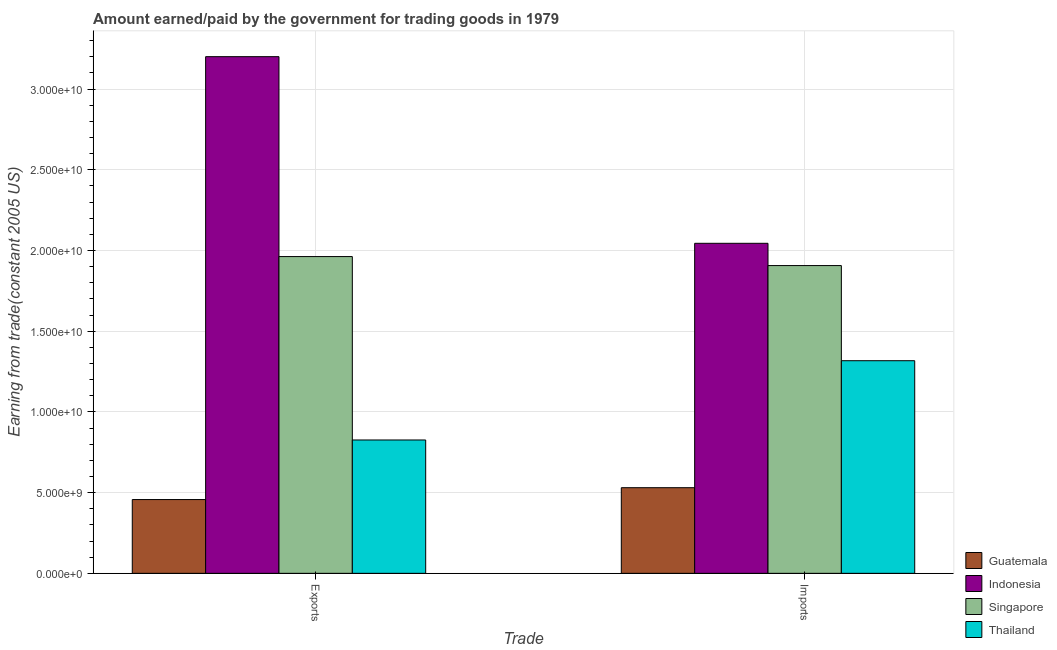How many different coloured bars are there?
Provide a succinct answer. 4. Are the number of bars on each tick of the X-axis equal?
Ensure brevity in your answer.  Yes. How many bars are there on the 2nd tick from the left?
Keep it short and to the point. 4. How many bars are there on the 2nd tick from the right?
Provide a succinct answer. 4. What is the label of the 1st group of bars from the left?
Your answer should be compact. Exports. What is the amount earned from exports in Guatemala?
Make the answer very short. 4.57e+09. Across all countries, what is the maximum amount earned from exports?
Provide a short and direct response. 3.20e+1. Across all countries, what is the minimum amount earned from exports?
Keep it short and to the point. 4.57e+09. In which country was the amount earned from exports minimum?
Your response must be concise. Guatemala. What is the total amount earned from exports in the graph?
Provide a succinct answer. 6.45e+1. What is the difference between the amount earned from exports in Singapore and that in Indonesia?
Keep it short and to the point. -1.24e+1. What is the difference between the amount paid for imports in Thailand and the amount earned from exports in Guatemala?
Provide a succinct answer. 8.60e+09. What is the average amount earned from exports per country?
Keep it short and to the point. 1.61e+1. What is the difference between the amount earned from exports and amount paid for imports in Guatemala?
Your response must be concise. -7.34e+08. What is the ratio of the amount earned from exports in Thailand to that in Guatemala?
Your response must be concise. 1.81. In how many countries, is the amount paid for imports greater than the average amount paid for imports taken over all countries?
Offer a terse response. 2. What does the 4th bar from the left in Imports represents?
Keep it short and to the point. Thailand. What does the 2nd bar from the right in Exports represents?
Offer a terse response. Singapore. Are all the bars in the graph horizontal?
Keep it short and to the point. No. Are the values on the major ticks of Y-axis written in scientific E-notation?
Ensure brevity in your answer.  Yes. Does the graph contain any zero values?
Make the answer very short. No. Does the graph contain grids?
Your answer should be very brief. Yes. Where does the legend appear in the graph?
Your answer should be compact. Bottom right. How many legend labels are there?
Your answer should be very brief. 4. What is the title of the graph?
Your response must be concise. Amount earned/paid by the government for trading goods in 1979. Does "Equatorial Guinea" appear as one of the legend labels in the graph?
Offer a very short reply. No. What is the label or title of the X-axis?
Your response must be concise. Trade. What is the label or title of the Y-axis?
Your response must be concise. Earning from trade(constant 2005 US). What is the Earning from trade(constant 2005 US) in Guatemala in Exports?
Give a very brief answer. 4.57e+09. What is the Earning from trade(constant 2005 US) of Indonesia in Exports?
Ensure brevity in your answer.  3.20e+1. What is the Earning from trade(constant 2005 US) in Singapore in Exports?
Offer a terse response. 1.96e+1. What is the Earning from trade(constant 2005 US) in Thailand in Exports?
Ensure brevity in your answer.  8.26e+09. What is the Earning from trade(constant 2005 US) in Guatemala in Imports?
Provide a short and direct response. 5.31e+09. What is the Earning from trade(constant 2005 US) in Indonesia in Imports?
Keep it short and to the point. 2.04e+1. What is the Earning from trade(constant 2005 US) of Singapore in Imports?
Your answer should be very brief. 1.91e+1. What is the Earning from trade(constant 2005 US) in Thailand in Imports?
Offer a terse response. 1.32e+1. Across all Trade, what is the maximum Earning from trade(constant 2005 US) in Guatemala?
Ensure brevity in your answer.  5.31e+09. Across all Trade, what is the maximum Earning from trade(constant 2005 US) of Indonesia?
Offer a very short reply. 3.20e+1. Across all Trade, what is the maximum Earning from trade(constant 2005 US) of Singapore?
Your answer should be compact. 1.96e+1. Across all Trade, what is the maximum Earning from trade(constant 2005 US) in Thailand?
Your answer should be compact. 1.32e+1. Across all Trade, what is the minimum Earning from trade(constant 2005 US) of Guatemala?
Offer a very short reply. 4.57e+09. Across all Trade, what is the minimum Earning from trade(constant 2005 US) in Indonesia?
Offer a very short reply. 2.04e+1. Across all Trade, what is the minimum Earning from trade(constant 2005 US) of Singapore?
Offer a very short reply. 1.91e+1. Across all Trade, what is the minimum Earning from trade(constant 2005 US) of Thailand?
Offer a very short reply. 8.26e+09. What is the total Earning from trade(constant 2005 US) in Guatemala in the graph?
Offer a terse response. 9.88e+09. What is the total Earning from trade(constant 2005 US) in Indonesia in the graph?
Your answer should be very brief. 5.25e+1. What is the total Earning from trade(constant 2005 US) in Singapore in the graph?
Make the answer very short. 3.87e+1. What is the total Earning from trade(constant 2005 US) of Thailand in the graph?
Ensure brevity in your answer.  2.14e+1. What is the difference between the Earning from trade(constant 2005 US) in Guatemala in Exports and that in Imports?
Keep it short and to the point. -7.34e+08. What is the difference between the Earning from trade(constant 2005 US) in Indonesia in Exports and that in Imports?
Keep it short and to the point. 1.16e+1. What is the difference between the Earning from trade(constant 2005 US) of Singapore in Exports and that in Imports?
Ensure brevity in your answer.  5.58e+08. What is the difference between the Earning from trade(constant 2005 US) of Thailand in Exports and that in Imports?
Provide a succinct answer. -4.91e+09. What is the difference between the Earning from trade(constant 2005 US) in Guatemala in Exports and the Earning from trade(constant 2005 US) in Indonesia in Imports?
Make the answer very short. -1.59e+1. What is the difference between the Earning from trade(constant 2005 US) in Guatemala in Exports and the Earning from trade(constant 2005 US) in Singapore in Imports?
Offer a terse response. -1.45e+1. What is the difference between the Earning from trade(constant 2005 US) in Guatemala in Exports and the Earning from trade(constant 2005 US) in Thailand in Imports?
Offer a very short reply. -8.60e+09. What is the difference between the Earning from trade(constant 2005 US) in Indonesia in Exports and the Earning from trade(constant 2005 US) in Singapore in Imports?
Give a very brief answer. 1.29e+1. What is the difference between the Earning from trade(constant 2005 US) of Indonesia in Exports and the Earning from trade(constant 2005 US) of Thailand in Imports?
Make the answer very short. 1.88e+1. What is the difference between the Earning from trade(constant 2005 US) in Singapore in Exports and the Earning from trade(constant 2005 US) in Thailand in Imports?
Keep it short and to the point. 6.45e+09. What is the average Earning from trade(constant 2005 US) of Guatemala per Trade?
Make the answer very short. 4.94e+09. What is the average Earning from trade(constant 2005 US) of Indonesia per Trade?
Your answer should be compact. 2.62e+1. What is the average Earning from trade(constant 2005 US) in Singapore per Trade?
Your answer should be compact. 1.93e+1. What is the average Earning from trade(constant 2005 US) of Thailand per Trade?
Your response must be concise. 1.07e+1. What is the difference between the Earning from trade(constant 2005 US) of Guatemala and Earning from trade(constant 2005 US) of Indonesia in Exports?
Your answer should be very brief. -2.74e+1. What is the difference between the Earning from trade(constant 2005 US) in Guatemala and Earning from trade(constant 2005 US) in Singapore in Exports?
Provide a short and direct response. -1.51e+1. What is the difference between the Earning from trade(constant 2005 US) of Guatemala and Earning from trade(constant 2005 US) of Thailand in Exports?
Provide a short and direct response. -3.69e+09. What is the difference between the Earning from trade(constant 2005 US) of Indonesia and Earning from trade(constant 2005 US) of Singapore in Exports?
Offer a very short reply. 1.24e+1. What is the difference between the Earning from trade(constant 2005 US) of Indonesia and Earning from trade(constant 2005 US) of Thailand in Exports?
Provide a short and direct response. 2.37e+1. What is the difference between the Earning from trade(constant 2005 US) of Singapore and Earning from trade(constant 2005 US) of Thailand in Exports?
Keep it short and to the point. 1.14e+1. What is the difference between the Earning from trade(constant 2005 US) in Guatemala and Earning from trade(constant 2005 US) in Indonesia in Imports?
Your answer should be very brief. -1.51e+1. What is the difference between the Earning from trade(constant 2005 US) in Guatemala and Earning from trade(constant 2005 US) in Singapore in Imports?
Give a very brief answer. -1.38e+1. What is the difference between the Earning from trade(constant 2005 US) of Guatemala and Earning from trade(constant 2005 US) of Thailand in Imports?
Your answer should be very brief. -7.87e+09. What is the difference between the Earning from trade(constant 2005 US) of Indonesia and Earning from trade(constant 2005 US) of Singapore in Imports?
Provide a succinct answer. 1.38e+09. What is the difference between the Earning from trade(constant 2005 US) of Indonesia and Earning from trade(constant 2005 US) of Thailand in Imports?
Your answer should be compact. 7.27e+09. What is the difference between the Earning from trade(constant 2005 US) of Singapore and Earning from trade(constant 2005 US) of Thailand in Imports?
Give a very brief answer. 5.89e+09. What is the ratio of the Earning from trade(constant 2005 US) in Guatemala in Exports to that in Imports?
Give a very brief answer. 0.86. What is the ratio of the Earning from trade(constant 2005 US) in Indonesia in Exports to that in Imports?
Offer a terse response. 1.57. What is the ratio of the Earning from trade(constant 2005 US) in Singapore in Exports to that in Imports?
Keep it short and to the point. 1.03. What is the ratio of the Earning from trade(constant 2005 US) of Thailand in Exports to that in Imports?
Your response must be concise. 0.63. What is the difference between the highest and the second highest Earning from trade(constant 2005 US) in Guatemala?
Give a very brief answer. 7.34e+08. What is the difference between the highest and the second highest Earning from trade(constant 2005 US) in Indonesia?
Offer a terse response. 1.16e+1. What is the difference between the highest and the second highest Earning from trade(constant 2005 US) of Singapore?
Offer a very short reply. 5.58e+08. What is the difference between the highest and the second highest Earning from trade(constant 2005 US) in Thailand?
Keep it short and to the point. 4.91e+09. What is the difference between the highest and the lowest Earning from trade(constant 2005 US) in Guatemala?
Keep it short and to the point. 7.34e+08. What is the difference between the highest and the lowest Earning from trade(constant 2005 US) of Indonesia?
Your answer should be very brief. 1.16e+1. What is the difference between the highest and the lowest Earning from trade(constant 2005 US) of Singapore?
Your answer should be very brief. 5.58e+08. What is the difference between the highest and the lowest Earning from trade(constant 2005 US) in Thailand?
Make the answer very short. 4.91e+09. 